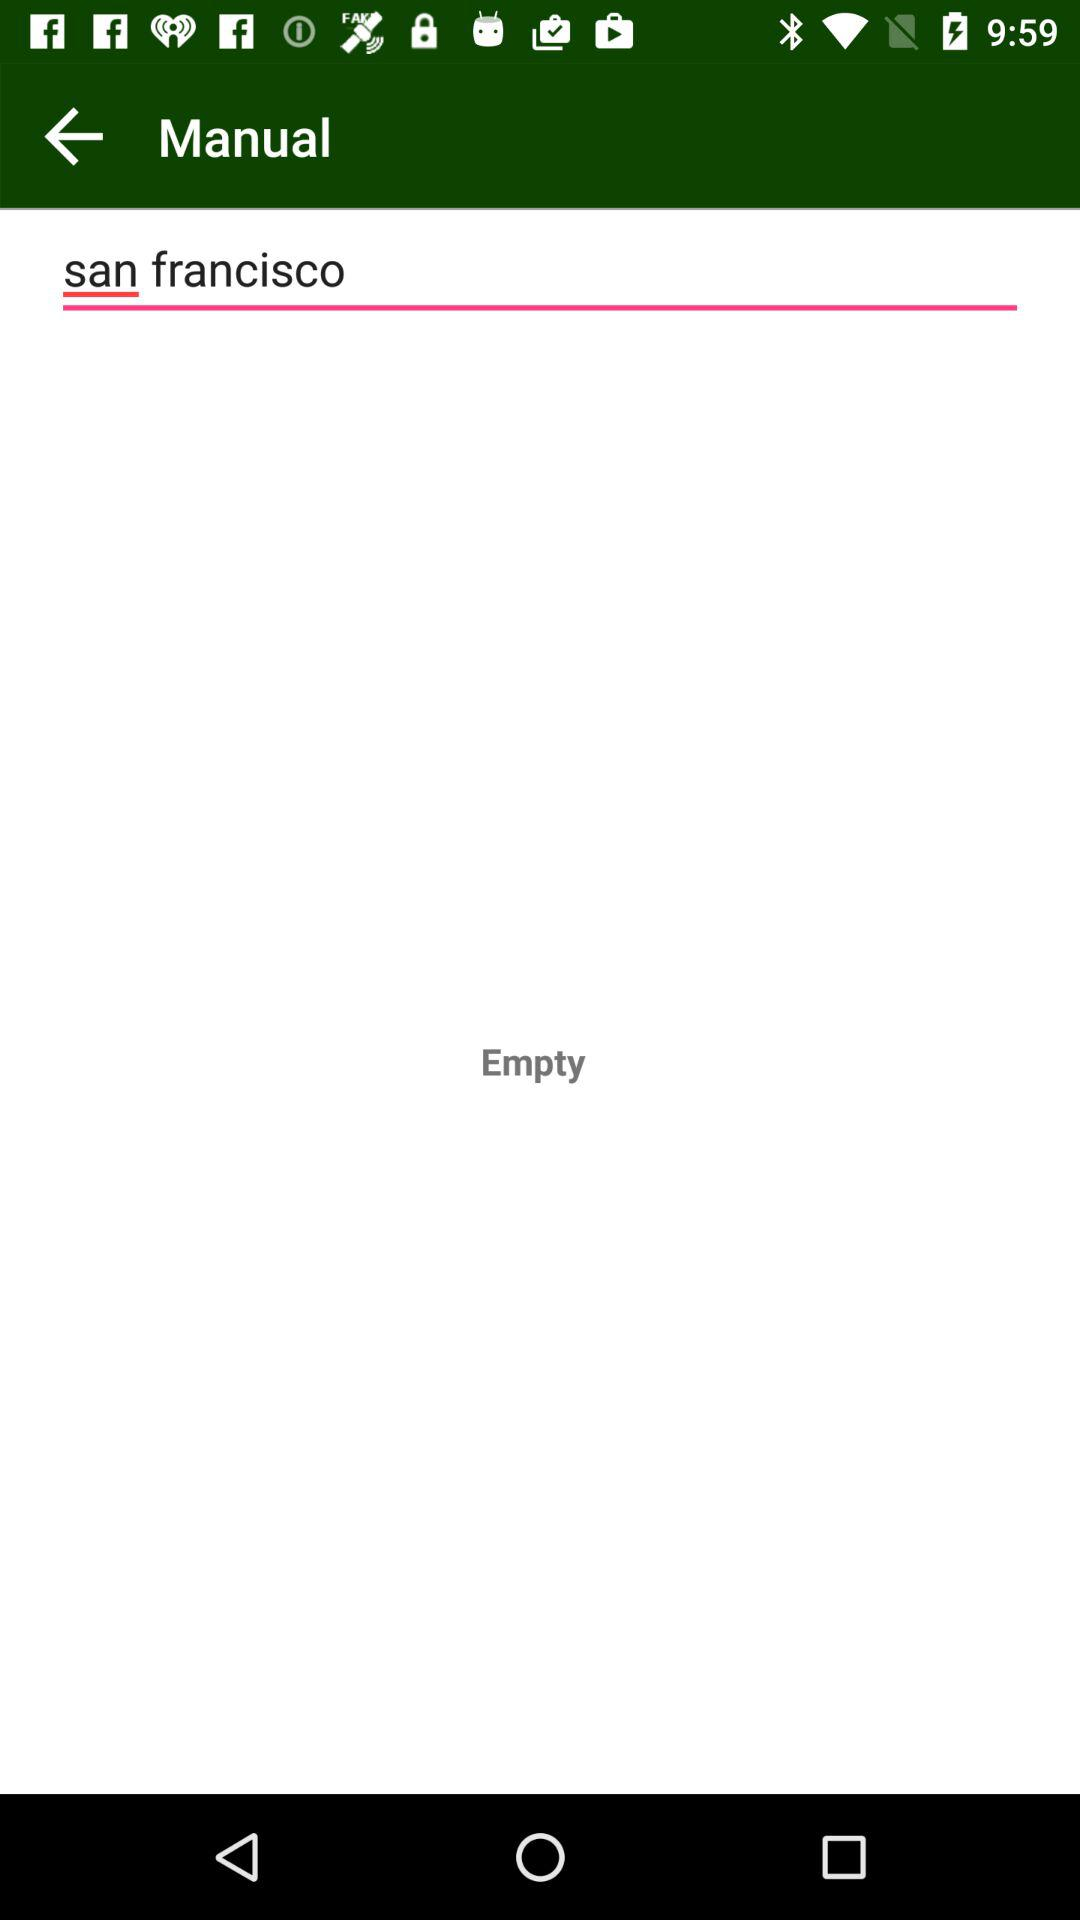What is the entered text? The entered text is San Francisco. 